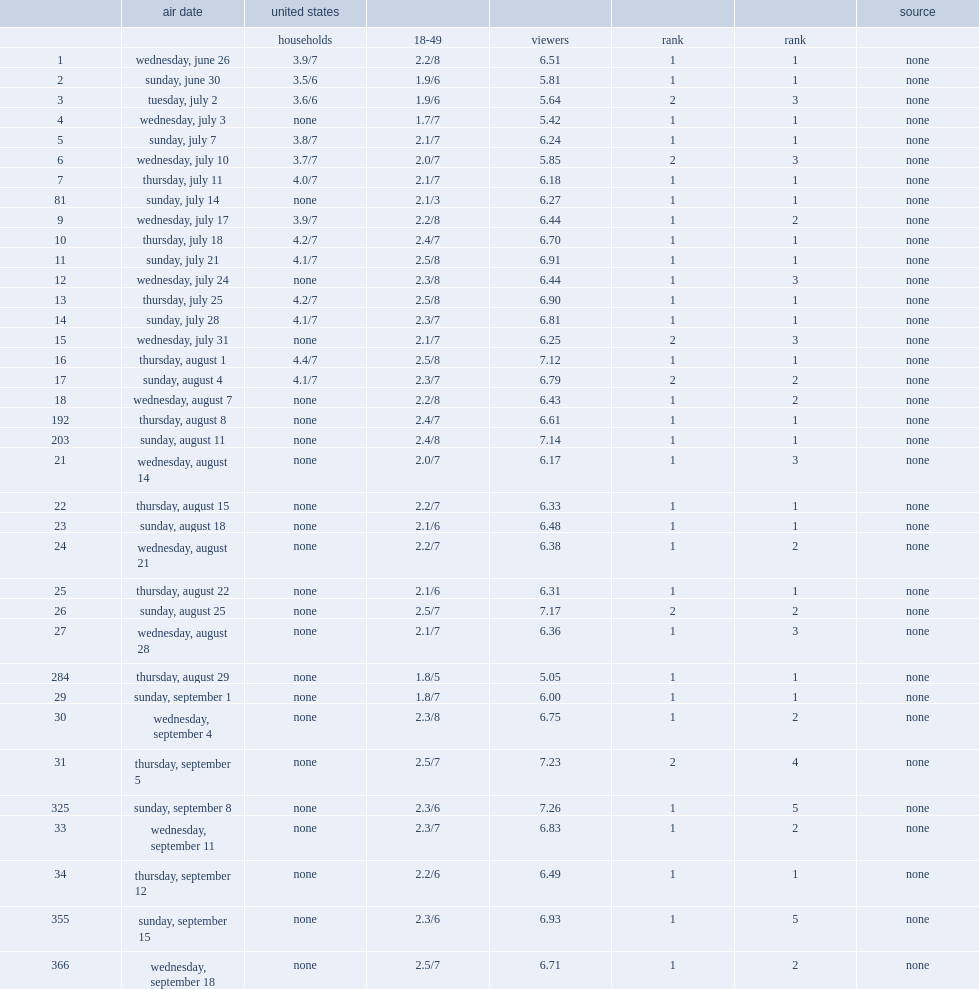How many viewers did the july 3 episode earn? 5.42. 